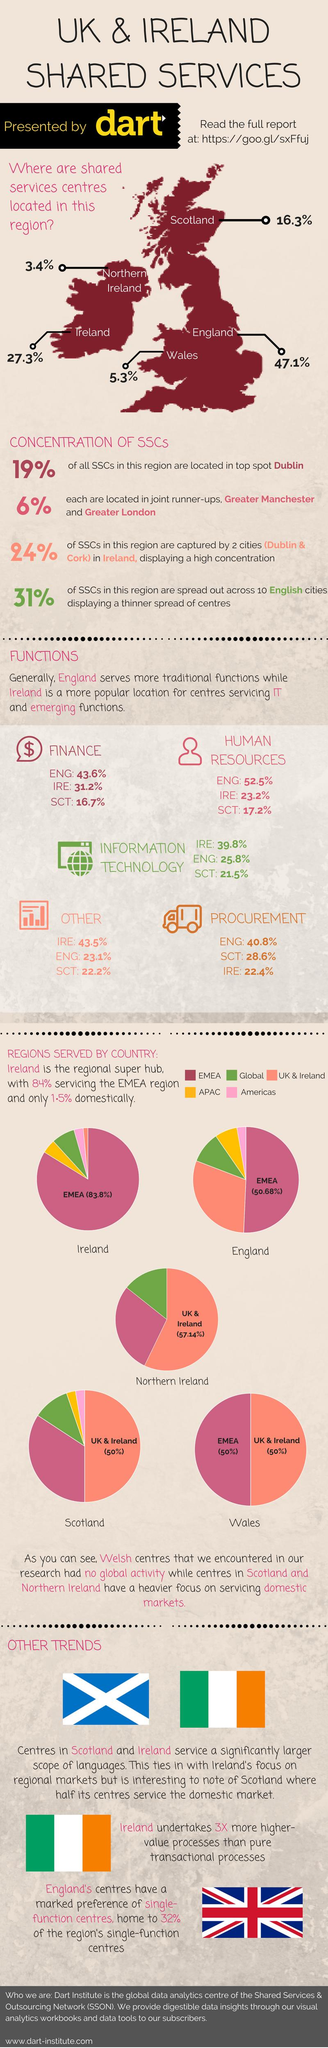Mention a couple of crucial points in this snapshot. According to the data, Scotland provides 28.6% of the services in procurement. England has the majority of its service centers in the EMEA region. Five service sectors have been mentioned. Five pie charts are present in this image. Five countries are named on the map. 